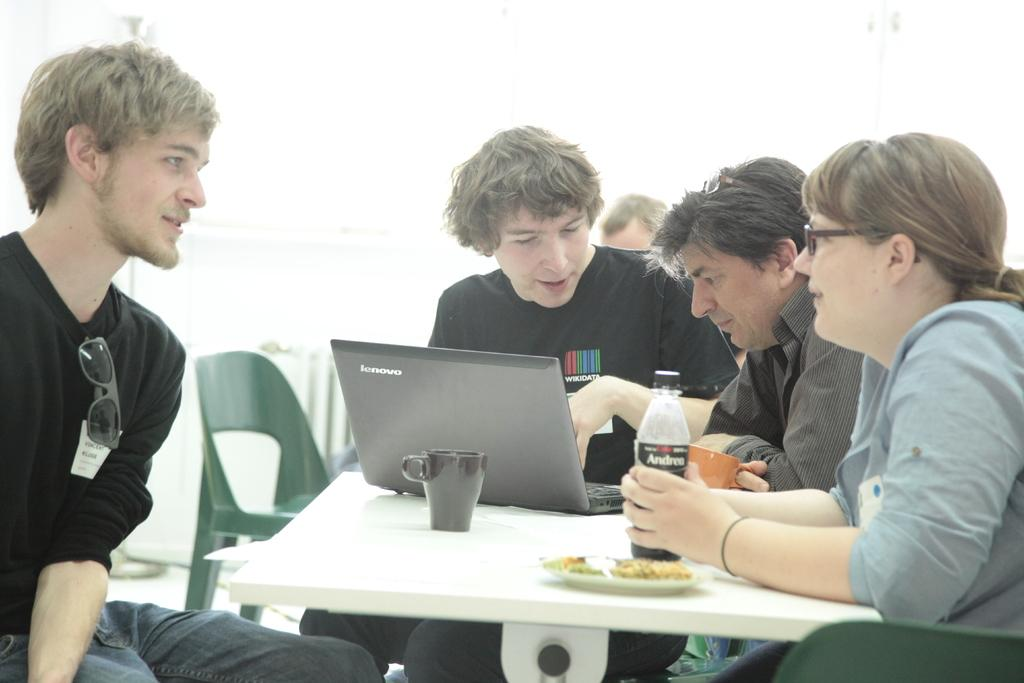How many people are in the image? There is a group of people in the image. What are the people doing in the image? The people are sitting on a chair. Where is the chair located in relation to the table? The chair is in front of a table. What can be seen on the table in the image? There are glass bottles, laptops, and other objects on the table. Can you hear the drum being played in the image? There is no drum present in the image, so it cannot be heard or seen. 